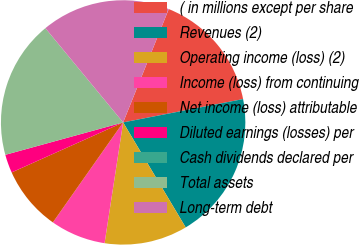Convert chart. <chart><loc_0><loc_0><loc_500><loc_500><pie_chart><fcel>( in millions except per share<fcel>Revenues (2)<fcel>Operating income (loss) (2)<fcel>Income (loss) from continuing<fcel>Net income (loss) attributable<fcel>Diluted earnings (losses) per<fcel>Cash dividends declared per<fcel>Total assets<fcel>Long-term debt<nl><fcel>15.85%<fcel>19.51%<fcel>10.98%<fcel>7.32%<fcel>8.54%<fcel>2.44%<fcel>0.0%<fcel>18.29%<fcel>17.07%<nl></chart> 